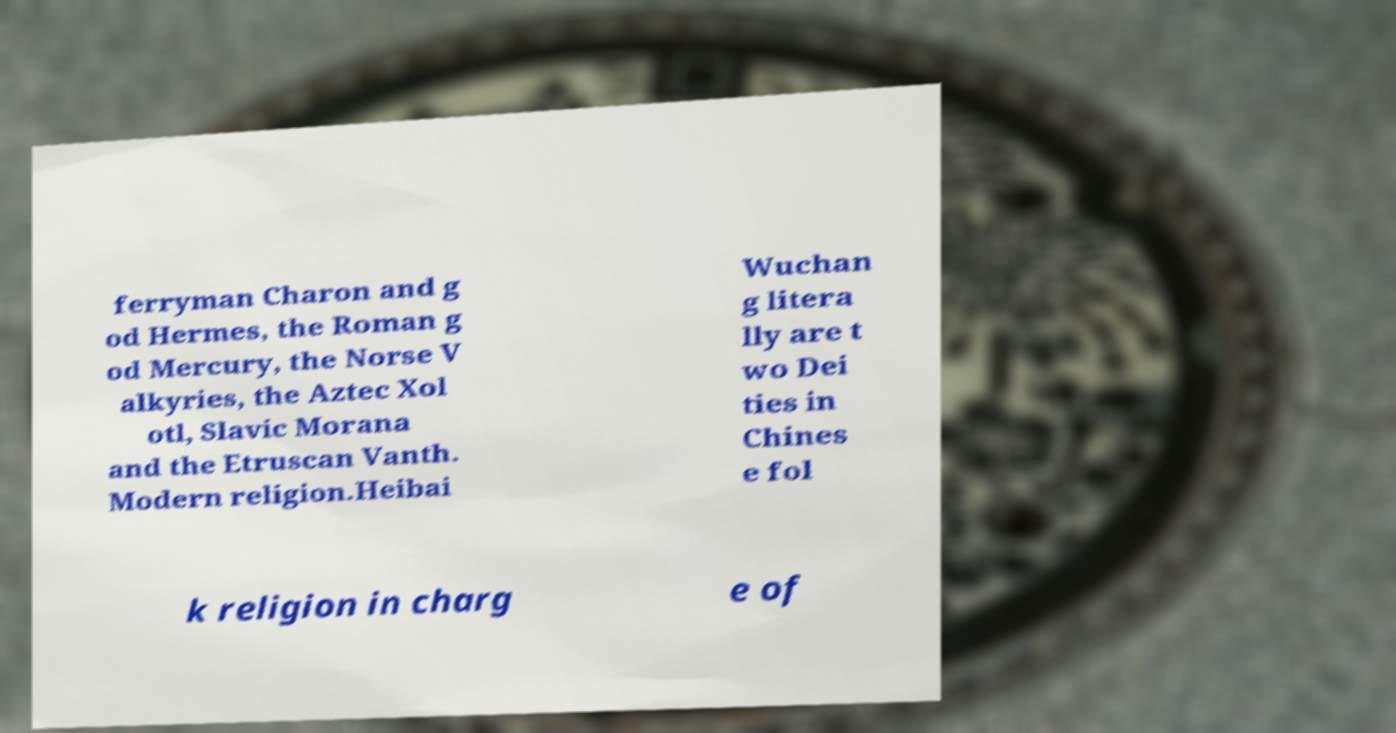What messages or text are displayed in this image? I need them in a readable, typed format. ferryman Charon and g od Hermes, the Roman g od Mercury, the Norse V alkyries, the Aztec Xol otl, Slavic Morana and the Etruscan Vanth. Modern religion.Heibai Wuchan g litera lly are t wo Dei ties in Chines e fol k religion in charg e of 